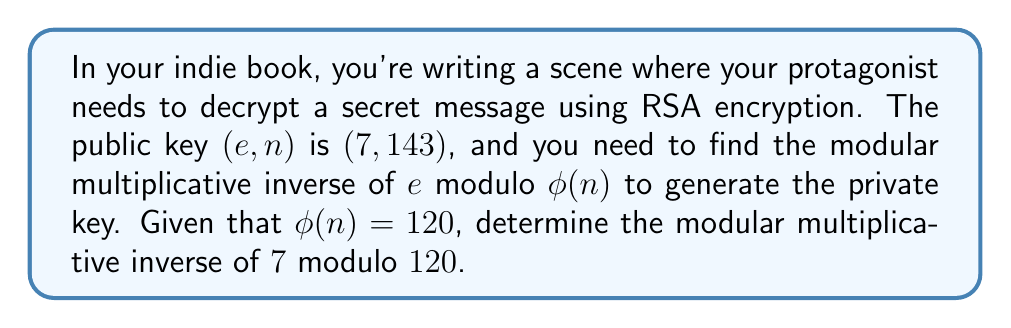Could you help me with this problem? To find the modular multiplicative inverse of $7$ modulo $120$, we need to find a number $d$ such that:

$$(7 \cdot d) \equiv 1 \pmod{120}$$

We can use the extended Euclidean algorithm to find this value:

1) Start with the equation: $120 = 17 \cdot 7 + 1$

2) Rearrange to isolate the remainder: $1 = 120 - 17 \cdot 7$

3) This means that $7^{-1} \equiv -17 \pmod{120}$

4) Since we want a positive number less than $120$, we add $120$ to $-17$:
   $-17 + 120 = 103$

Therefore, $7^{-1} \equiv 103 \pmod{120}$

We can verify this:
$$(7 \cdot 103) \mod 120 = 721 \mod 120 = 1$$

So, the modular multiplicative inverse of $7$ modulo $120$ is $103$.
Answer: $103$ 